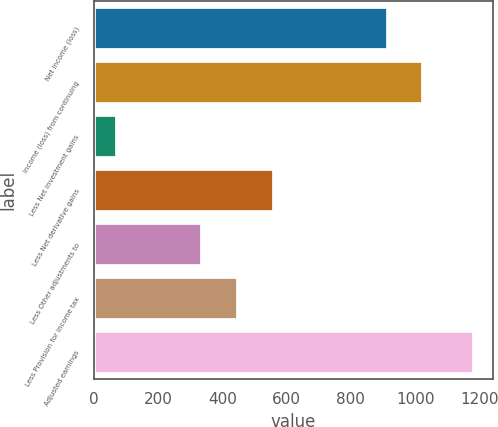Convert chart to OTSL. <chart><loc_0><loc_0><loc_500><loc_500><bar_chart><fcel>Net income (loss)<fcel>Income (loss) from continuing<fcel>Less Net investment gains<fcel>Less Net derivative gains<fcel>Less Other adjustments to<fcel>Less Provision for income tax<fcel>Adjusted earnings<nl><fcel>914<fcel>1025.1<fcel>71<fcel>559.2<fcel>337<fcel>448.1<fcel>1182<nl></chart> 